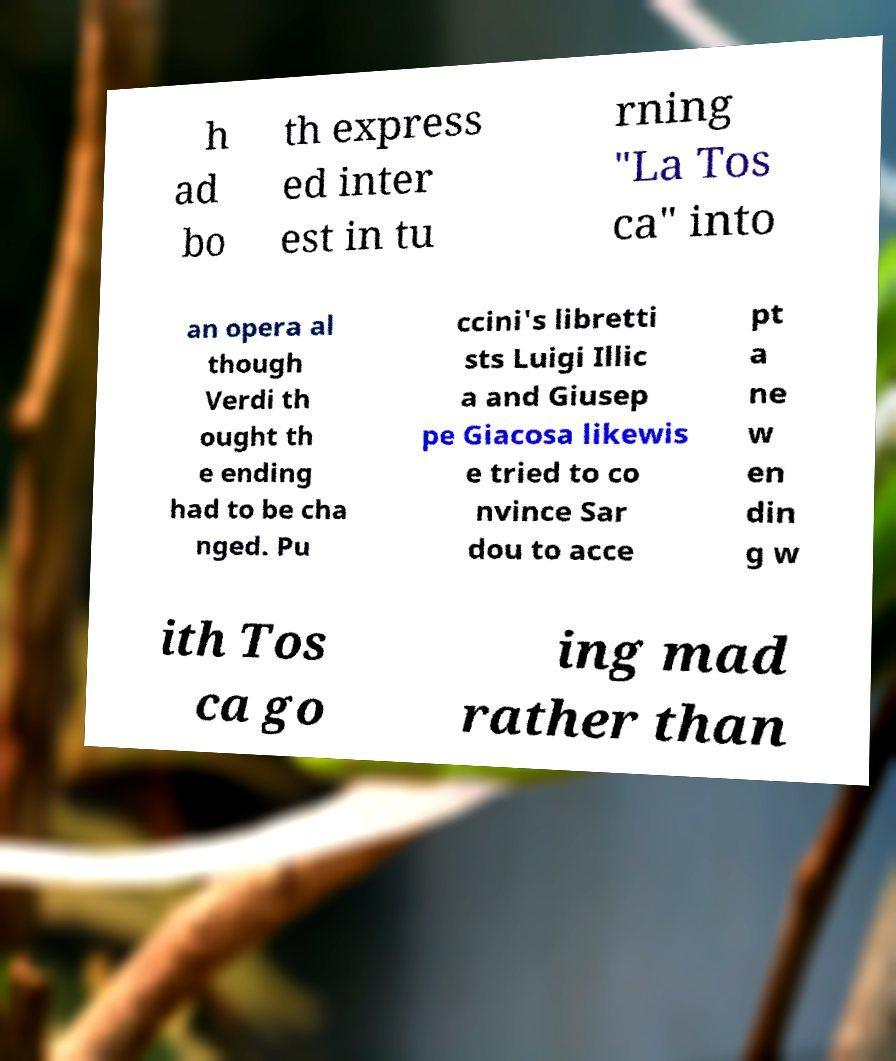Can you read and provide the text displayed in the image?This photo seems to have some interesting text. Can you extract and type it out for me? h ad bo th express ed inter est in tu rning "La Tos ca" into an opera al though Verdi th ought th e ending had to be cha nged. Pu ccini's libretti sts Luigi Illic a and Giusep pe Giacosa likewis e tried to co nvince Sar dou to acce pt a ne w en din g w ith Tos ca go ing mad rather than 